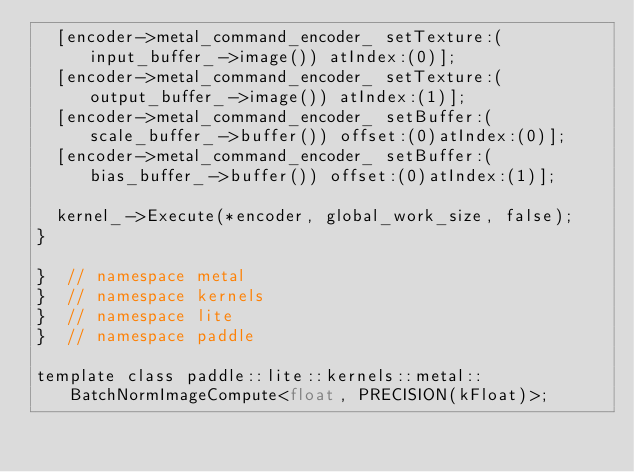<code> <loc_0><loc_0><loc_500><loc_500><_ObjectiveC_>  [encoder->metal_command_encoder_ setTexture:(input_buffer_->image()) atIndex:(0)];
  [encoder->metal_command_encoder_ setTexture:(output_buffer_->image()) atIndex:(1)];
  [encoder->metal_command_encoder_ setBuffer:(scale_buffer_->buffer()) offset:(0)atIndex:(0)];
  [encoder->metal_command_encoder_ setBuffer:(bias_buffer_->buffer()) offset:(0)atIndex:(1)];

  kernel_->Execute(*encoder, global_work_size, false);
}

}  // namespace metal
}  // namespace kernels
}  // namespace lite
}  // namespace paddle

template class paddle::lite::kernels::metal::BatchNormImageCompute<float, PRECISION(kFloat)>;</code> 